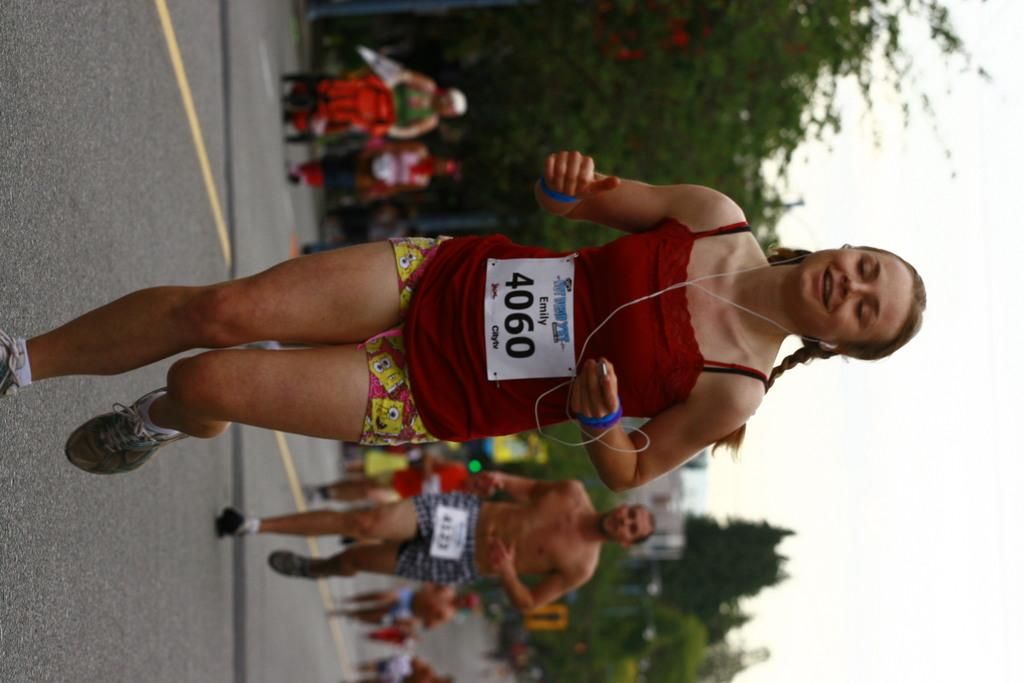<image>
Relay a brief, clear account of the picture shown. Person wearing a red shirt with a label that says 4060 on it. 